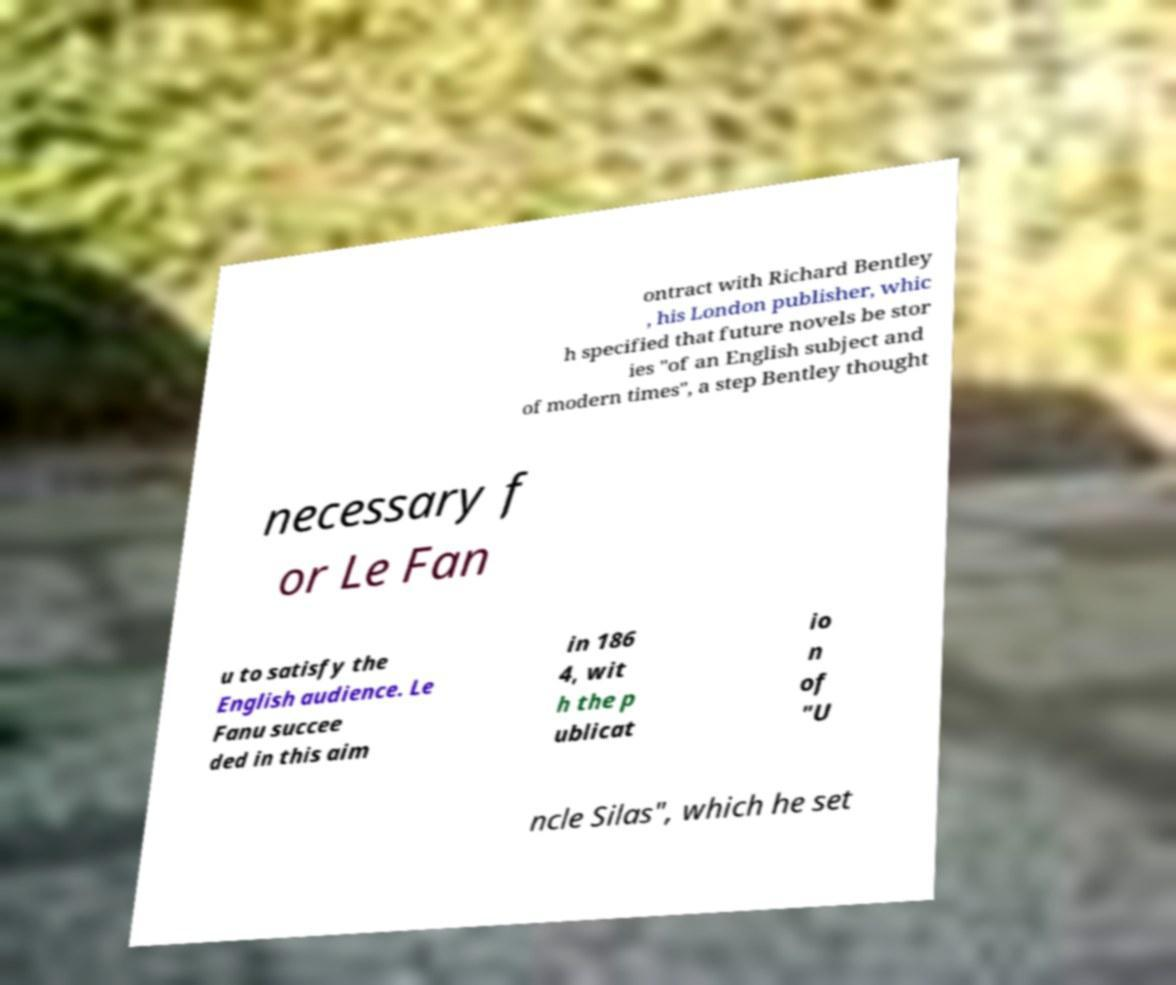Could you extract and type out the text from this image? ontract with Richard Bentley , his London publisher, whic h specified that future novels be stor ies "of an English subject and of modern times", a step Bentley thought necessary f or Le Fan u to satisfy the English audience. Le Fanu succee ded in this aim in 186 4, wit h the p ublicat io n of "U ncle Silas", which he set 